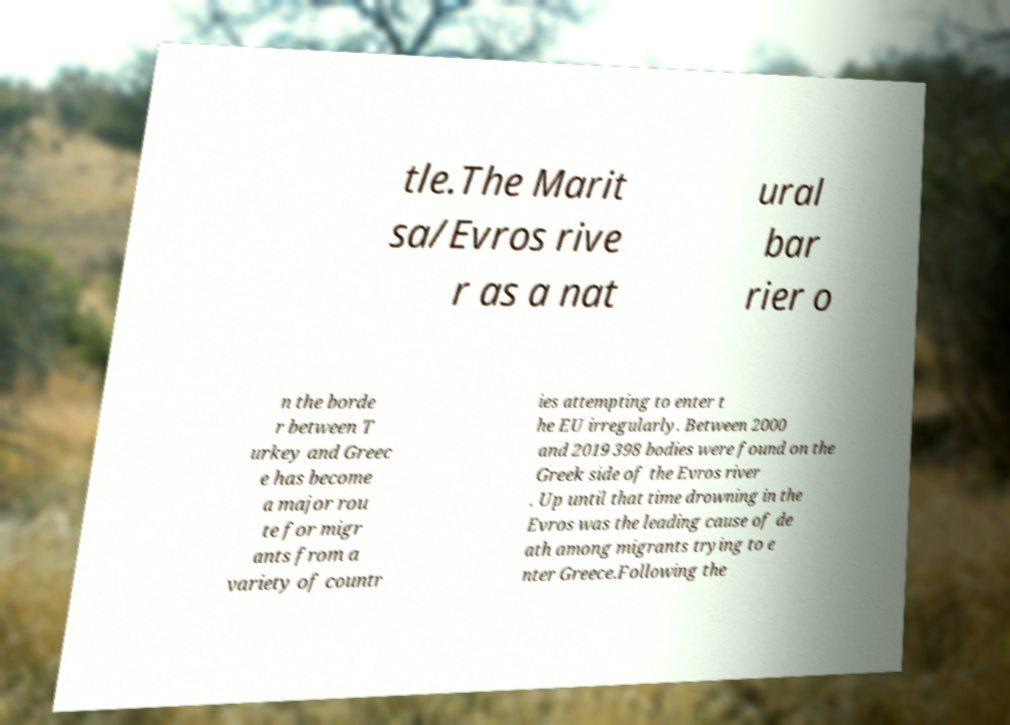Can you read and provide the text displayed in the image?This photo seems to have some interesting text. Can you extract and type it out for me? tle.The Marit sa/Evros rive r as a nat ural bar rier o n the borde r between T urkey and Greec e has become a major rou te for migr ants from a variety of countr ies attempting to enter t he EU irregularly. Between 2000 and 2019 398 bodies were found on the Greek side of the Evros river . Up until that time drowning in the Evros was the leading cause of de ath among migrants trying to e nter Greece.Following the 